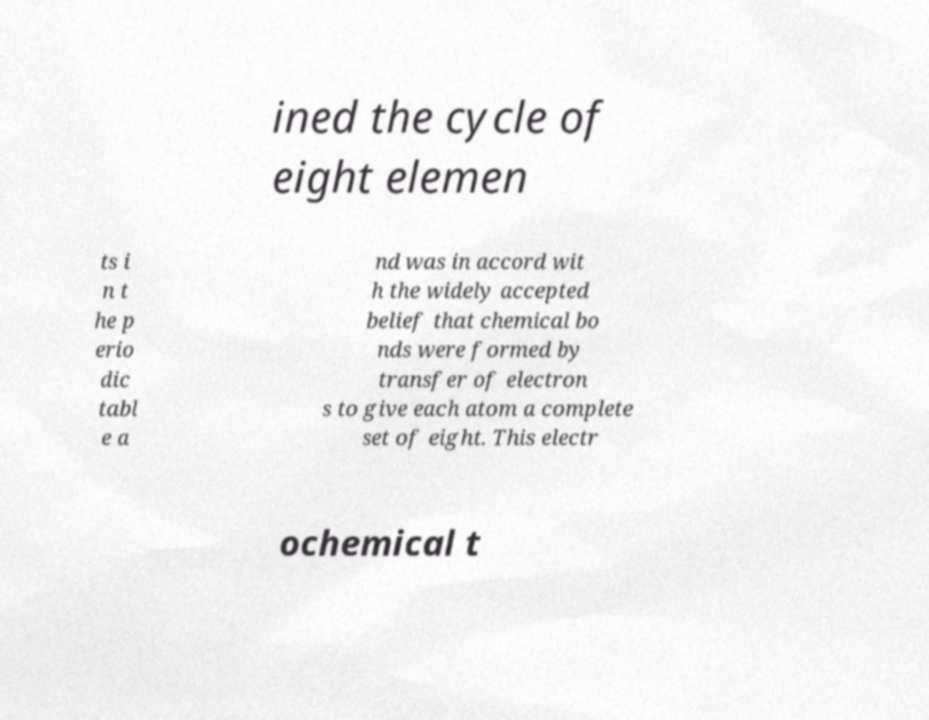Can you accurately transcribe the text from the provided image for me? ined the cycle of eight elemen ts i n t he p erio dic tabl e a nd was in accord wit h the widely accepted belief that chemical bo nds were formed by transfer of electron s to give each atom a complete set of eight. This electr ochemical t 